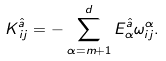Convert formula to latex. <formula><loc_0><loc_0><loc_500><loc_500>K ^ { \hat { a } } _ { \, i j } = - \sum _ { \alpha = m + 1 } ^ { d } E ^ { \hat { a } } _ { \alpha } \omega ^ { \alpha } _ { i j } .</formula> 